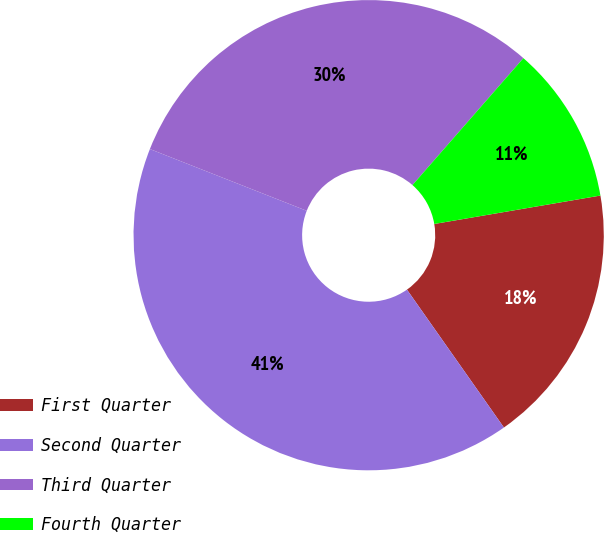Convert chart to OTSL. <chart><loc_0><loc_0><loc_500><loc_500><pie_chart><fcel>First Quarter<fcel>Second Quarter<fcel>Third Quarter<fcel>Fourth Quarter<nl><fcel>17.94%<fcel>40.72%<fcel>30.46%<fcel>10.87%<nl></chart> 